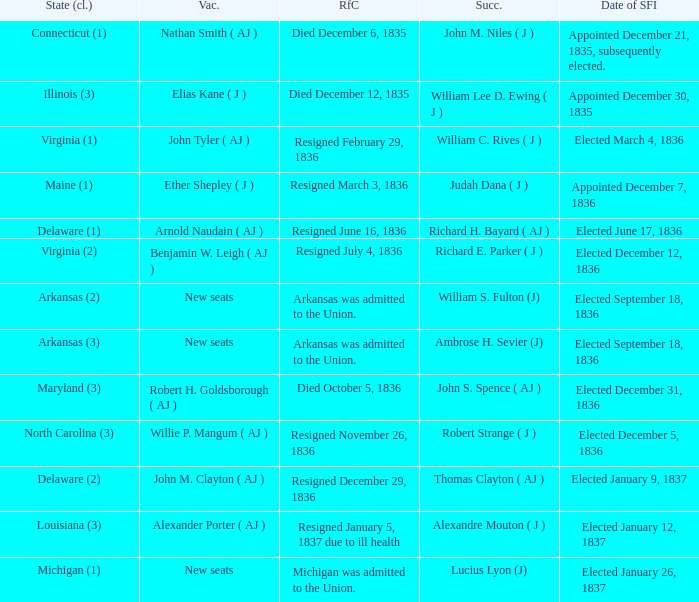Name the successor for elected january 26, 1837 1.0. 